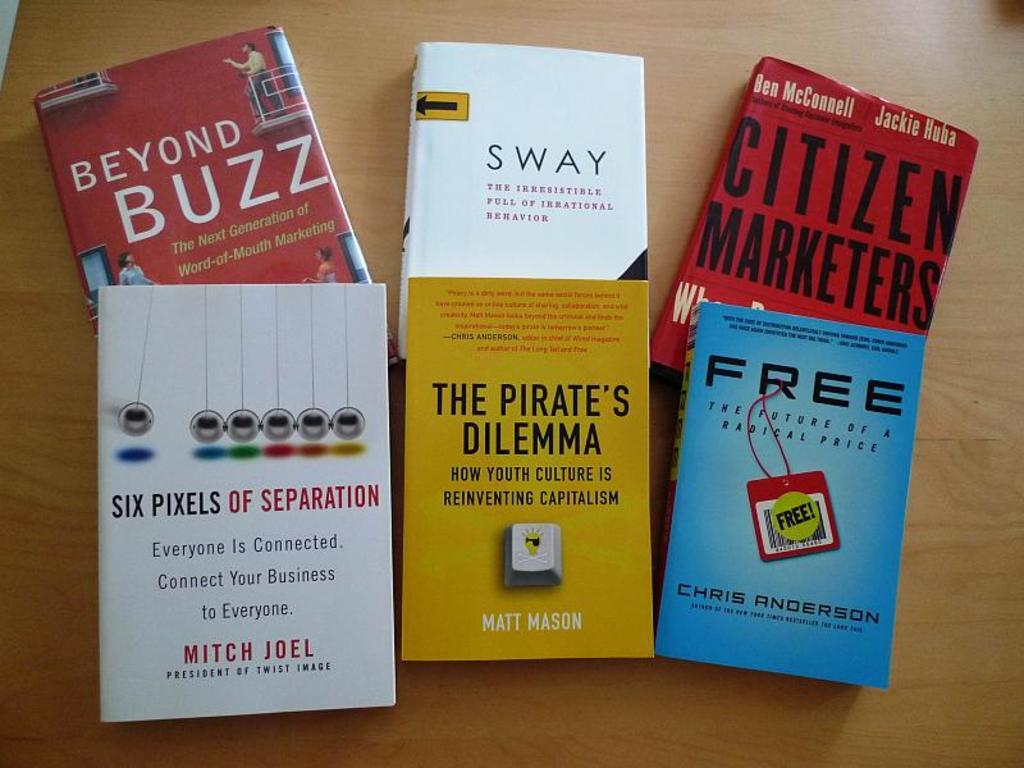Provide a one-sentence caption for the provided image. 6 books on the table called free, the pirates dilemman. 